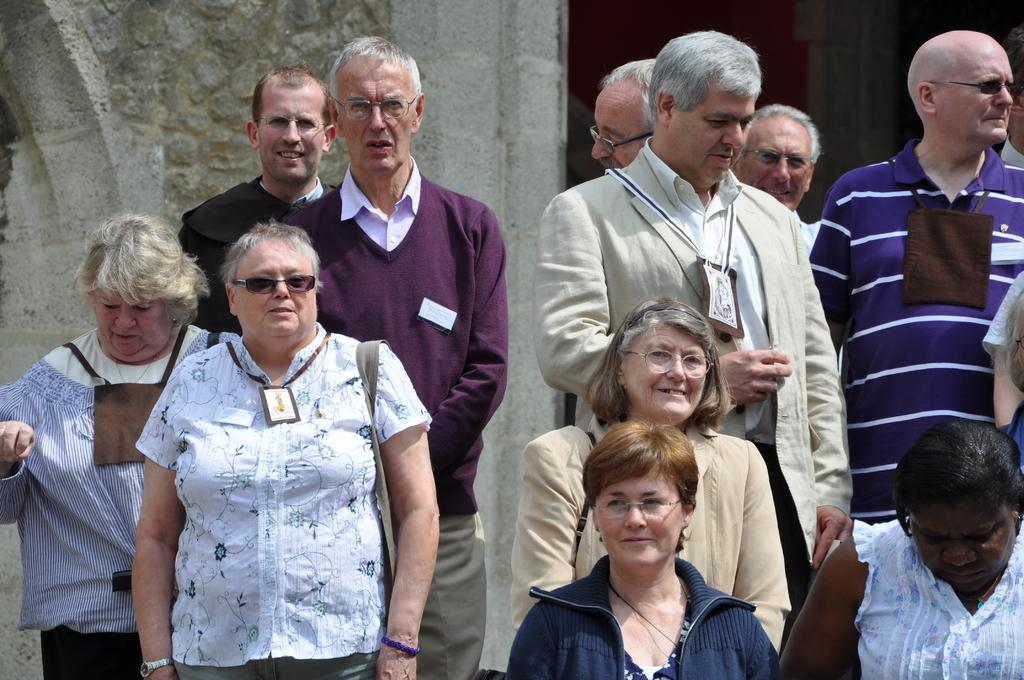How many people are in the image? There is a group of people in the image, but the exact number is not specified. What are the people doing in the image? The people are standing on a path in the image. What is behind the people in the image? There is a wall behind the people in the image. How many plates are on the wall in the image? There are no plates visible on the wall in the image. Can you see any sheep running in the image? There are no sheep or running depicted in the image. 